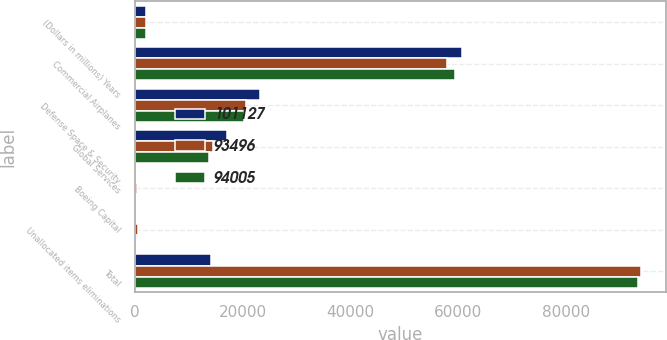Convert chart. <chart><loc_0><loc_0><loc_500><loc_500><stacked_bar_chart><ecel><fcel>(Dollars in millions) Years<fcel>Commercial Airplanes<fcel>Defense Space & Security<fcel>Global Services<fcel>Boeing Capital<fcel>Unallocated items eliminations<fcel>Total<nl><fcel>101127<fcel>2018<fcel>60715<fcel>23195<fcel>17018<fcel>274<fcel>75<fcel>14200<nl><fcel>93496<fcel>2017<fcel>58014<fcel>20561<fcel>14581<fcel>307<fcel>542<fcel>94005<nl><fcel>94005<fcel>2016<fcel>59378<fcel>20180<fcel>13819<fcel>298<fcel>179<fcel>93496<nl></chart> 